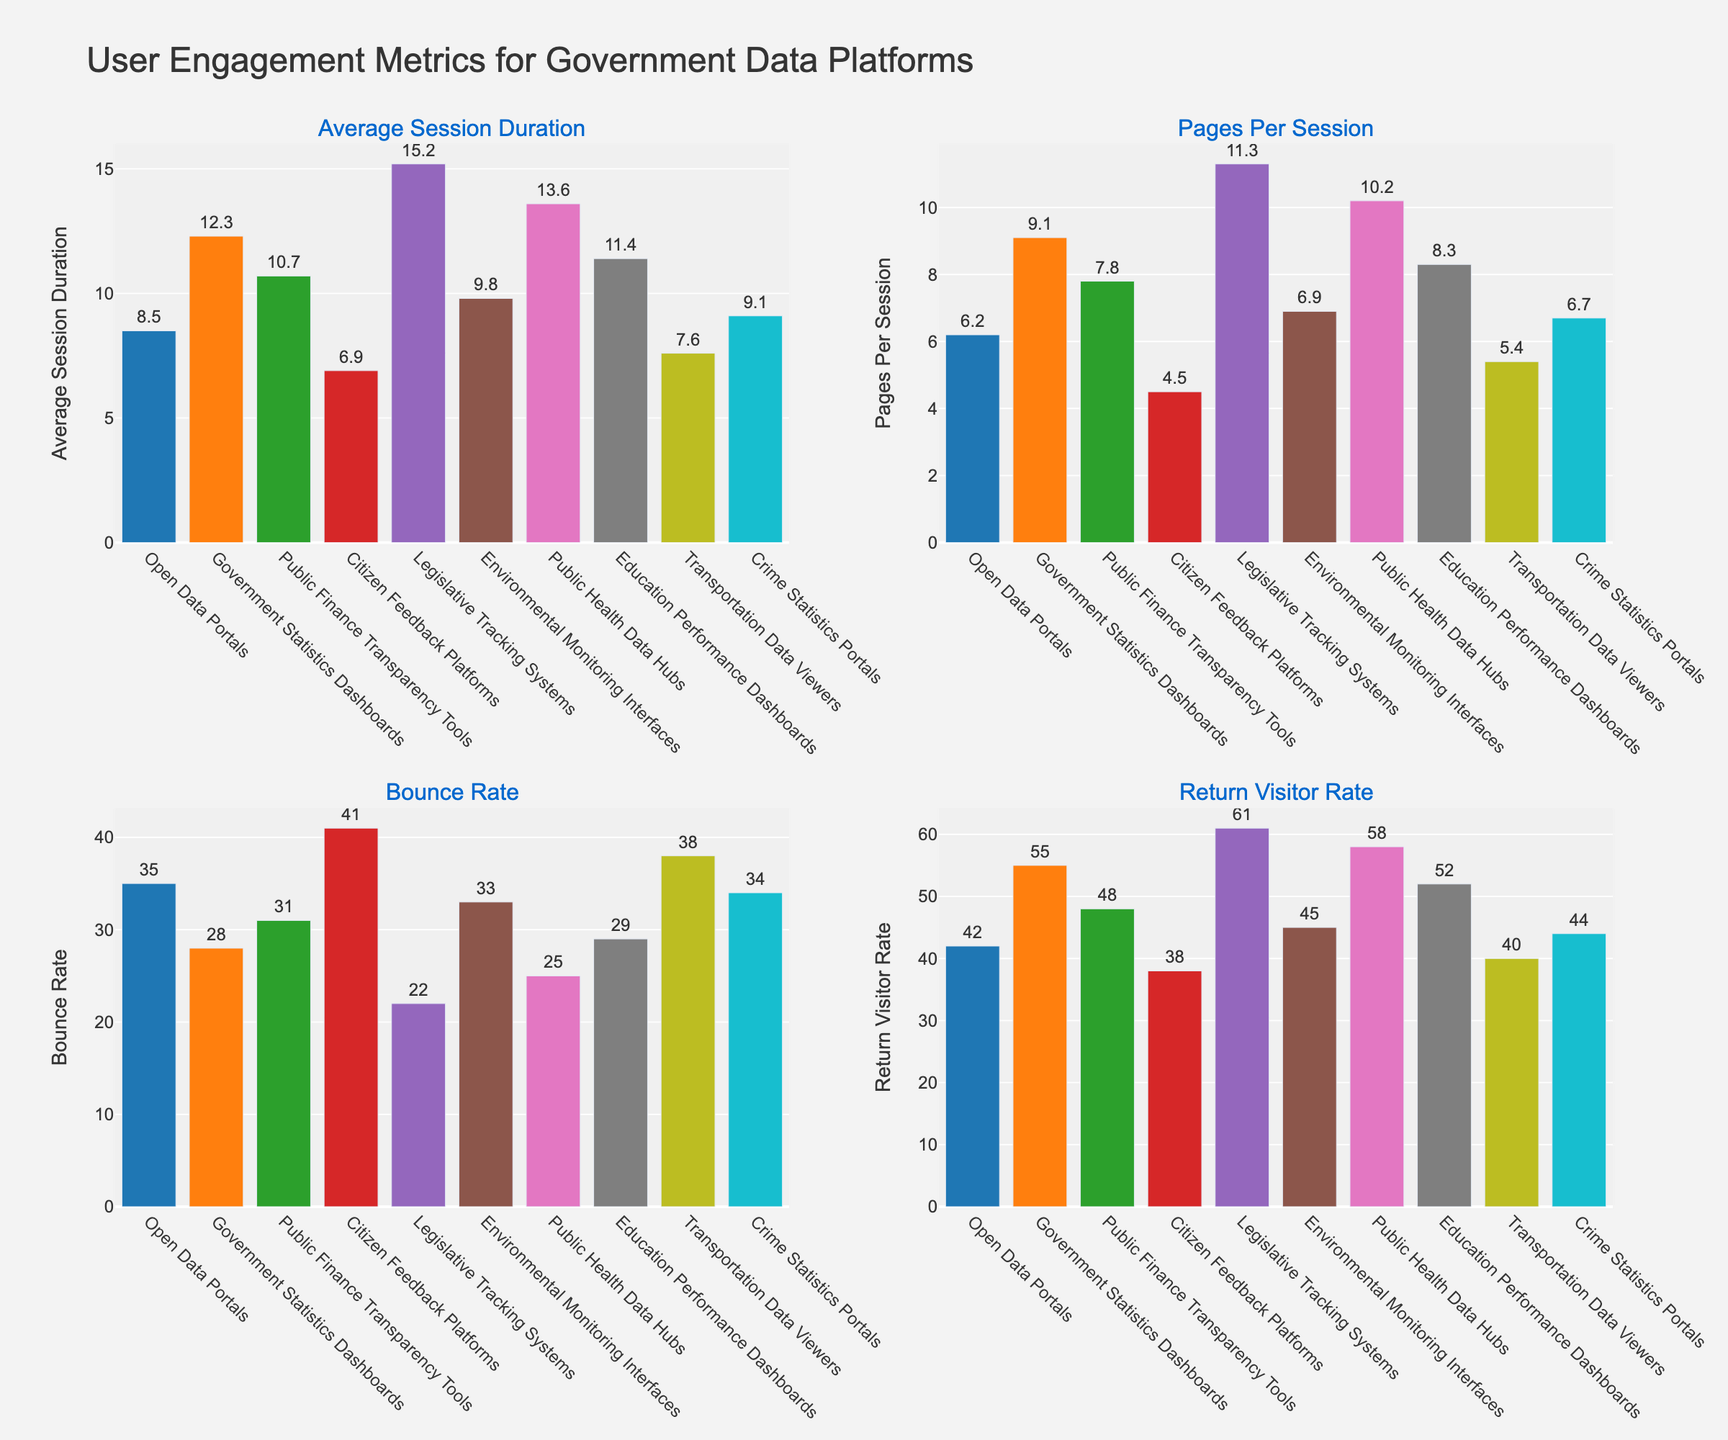Which platform has the highest average session duration? The platform with the highest average session duration is represented by the tallest bar in the "Average Session Duration" subplot. By observing the plot, we find that Legislative Tracking Systems has the highest bar at 15.2 minutes.
Answer: Legislative Tracking Systems Which platform has the lowest return visitor rate? The platform with the lowest return visitor rate is represented by the shortest bar in the "Return Visitor Rate" subplot. By viewing the subplot, we see that Citizen Feedback Platforms has the lowest bar at 38%.
Answer: Citizen Feedback Platforms Are there any platforms that have a bounce rate less than 30%? Platforms with a bounce rate less than 30% have bars shorter than the 30% mark in the "Bounce Rate" subplot. Both Government Statistics Dashboards (28%) and Public Health Data Hubs (25%) have bounce rates less than 30%.
Answer: Yes, Government Statistics Dashboards and Public Health Data Hubs Which platform has more pages per session: Environmental Monitoring Interfaces or Transportation Data Viewers? By comparing the bar heights in the "Pages Per Session" subplot, Environmental Monitoring Interfaces has a bar of 6.9, and Transportation Data Viewers has a bar of 5.4. Therefore, Environmental Monitoring Interfaces has more pages per session.
Answer: Environmental Monitoring Interfaces Calculate the difference in average session duration between Legislative Tracking Systems and Citizen Feedback Platforms. To find the difference, subtract the average session duration of Citizen Feedback Platforms (6.9) from Legislative Tracking Systems (15.2). The difference is 15.2 - 6.9 = 8.3 minutes.
Answer: 8.3 minutes Which platform has the highest pages per session? The platform with the highest pages per session is represented by the tallest bar in the "Pages Per Session" subplot. Legislative Tracking Systems has the highest bar at 11.3 pages per session.
Answer: Legislative Tracking Systems Compare the bounce rates of Crime Statistics Portals and Transportation Data Viewers. Which one is higher? By observing the "Bounce Rate" subplot, Crime Statistics Portals has a bounce rate of 34%, while Transportation Data Viewers has a bounce rate of 38%. Therefore, Transportation Data Viewers has a higher bounce rate.
Answer: Transportation Data Viewers How many platforms have a return visitor rate of more than 50%? By examining the "Return Visitor Rate" subplot, the platforms with bars above the 50% mark are: Government Statistics Dashboards (55%), Legislative Tracking Systems (61%), Public Health Data Hubs (58%), and Education Performance Dashboards (52%). Four platforms meet this criterion.
Answer: Four platforms 